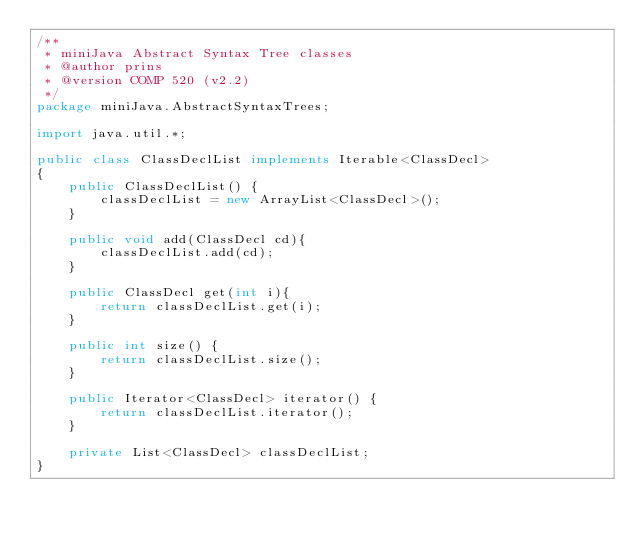Convert code to text. <code><loc_0><loc_0><loc_500><loc_500><_Java_>/**
 * miniJava Abstract Syntax Tree classes
 * @author prins
 * @version COMP 520 (v2.2)
 */
package miniJava.AbstractSyntaxTrees;

import java.util.*;

public class ClassDeclList implements Iterable<ClassDecl>
{
	public ClassDeclList() {
		classDeclList = new ArrayList<ClassDecl>();
	}   

	public void add(ClassDecl cd){
		classDeclList.add(cd);
	}

	public ClassDecl get(int i){
		return classDeclList.get(i);
	}

	public int size() {
		return classDeclList.size();
	}

	public Iterator<ClassDecl> iterator() {
		return classDeclList.iterator();
	}

	private List<ClassDecl> classDeclList;
}

</code> 